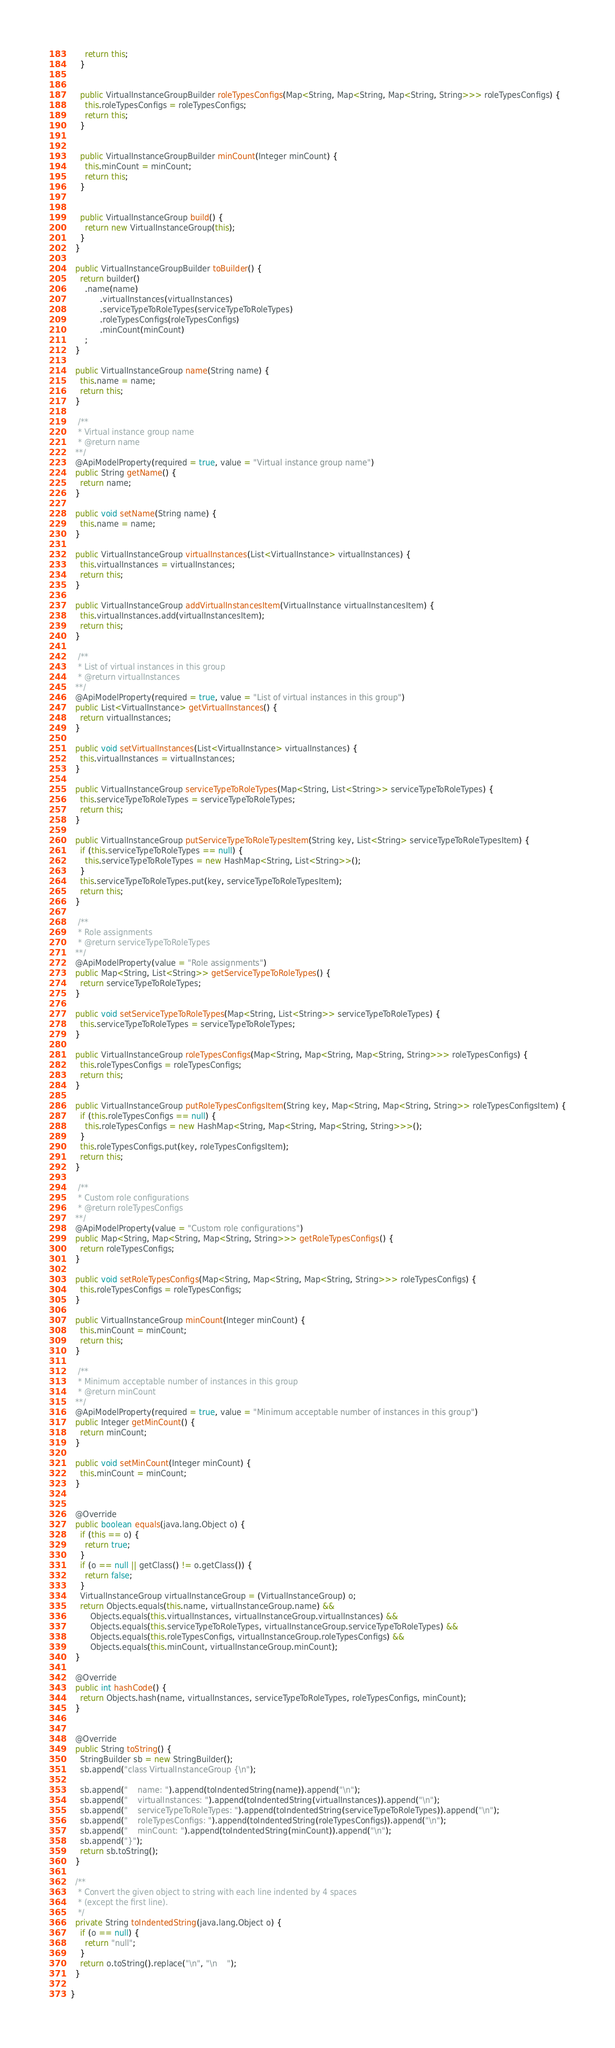Convert code to text. <code><loc_0><loc_0><loc_500><loc_500><_Java_>      return this;
    }


    public VirtualInstanceGroupBuilder roleTypesConfigs(Map<String, Map<String, Map<String, String>>> roleTypesConfigs) {
      this.roleTypesConfigs = roleTypesConfigs;
      return this;
    }


    public VirtualInstanceGroupBuilder minCount(Integer minCount) {
      this.minCount = minCount;
      return this;
    }


    public VirtualInstanceGroup build() {
      return new VirtualInstanceGroup(this);
    }
  }

  public VirtualInstanceGroupBuilder toBuilder() {
    return builder()
      .name(name)
            .virtualInstances(virtualInstances)
            .serviceTypeToRoleTypes(serviceTypeToRoleTypes)
            .roleTypesConfigs(roleTypesConfigs)
            .minCount(minCount)
      ;
  }

  public VirtualInstanceGroup name(String name) {
    this.name = name;
    return this;
  }

   /**
   * Virtual instance group name
   * @return name
  **/
  @ApiModelProperty(required = true, value = "Virtual instance group name")
  public String getName() {
    return name;
  }

  public void setName(String name) {
    this.name = name;
  }

  public VirtualInstanceGroup virtualInstances(List<VirtualInstance> virtualInstances) {
    this.virtualInstances = virtualInstances;
    return this;
  }

  public VirtualInstanceGroup addVirtualInstancesItem(VirtualInstance virtualInstancesItem) {
    this.virtualInstances.add(virtualInstancesItem);
    return this;
  }

   /**
   * List of virtual instances in this group
   * @return virtualInstances
  **/
  @ApiModelProperty(required = true, value = "List of virtual instances in this group")
  public List<VirtualInstance> getVirtualInstances() {
    return virtualInstances;
  }

  public void setVirtualInstances(List<VirtualInstance> virtualInstances) {
    this.virtualInstances = virtualInstances;
  }

  public VirtualInstanceGroup serviceTypeToRoleTypes(Map<String, List<String>> serviceTypeToRoleTypes) {
    this.serviceTypeToRoleTypes = serviceTypeToRoleTypes;
    return this;
  }

  public VirtualInstanceGroup putServiceTypeToRoleTypesItem(String key, List<String> serviceTypeToRoleTypesItem) {
    if (this.serviceTypeToRoleTypes == null) {
      this.serviceTypeToRoleTypes = new HashMap<String, List<String>>();
    }
    this.serviceTypeToRoleTypes.put(key, serviceTypeToRoleTypesItem);
    return this;
  }

   /**
   * Role assignments
   * @return serviceTypeToRoleTypes
  **/
  @ApiModelProperty(value = "Role assignments")
  public Map<String, List<String>> getServiceTypeToRoleTypes() {
    return serviceTypeToRoleTypes;
  }

  public void setServiceTypeToRoleTypes(Map<String, List<String>> serviceTypeToRoleTypes) {
    this.serviceTypeToRoleTypes = serviceTypeToRoleTypes;
  }

  public VirtualInstanceGroup roleTypesConfigs(Map<String, Map<String, Map<String, String>>> roleTypesConfigs) {
    this.roleTypesConfigs = roleTypesConfigs;
    return this;
  }

  public VirtualInstanceGroup putRoleTypesConfigsItem(String key, Map<String, Map<String, String>> roleTypesConfigsItem) {
    if (this.roleTypesConfigs == null) {
      this.roleTypesConfigs = new HashMap<String, Map<String, Map<String, String>>>();
    }
    this.roleTypesConfigs.put(key, roleTypesConfigsItem);
    return this;
  }

   /**
   * Custom role configurations
   * @return roleTypesConfigs
  **/
  @ApiModelProperty(value = "Custom role configurations")
  public Map<String, Map<String, Map<String, String>>> getRoleTypesConfigs() {
    return roleTypesConfigs;
  }

  public void setRoleTypesConfigs(Map<String, Map<String, Map<String, String>>> roleTypesConfigs) {
    this.roleTypesConfigs = roleTypesConfigs;
  }

  public VirtualInstanceGroup minCount(Integer minCount) {
    this.minCount = minCount;
    return this;
  }

   /**
   * Minimum acceptable number of instances in this group
   * @return minCount
  **/
  @ApiModelProperty(required = true, value = "Minimum acceptable number of instances in this group")
  public Integer getMinCount() {
    return minCount;
  }

  public void setMinCount(Integer minCount) {
    this.minCount = minCount;
  }


  @Override
  public boolean equals(java.lang.Object o) {
    if (this == o) {
      return true;
    }
    if (o == null || getClass() != o.getClass()) {
      return false;
    }
    VirtualInstanceGroup virtualInstanceGroup = (VirtualInstanceGroup) o;
    return Objects.equals(this.name, virtualInstanceGroup.name) &&
        Objects.equals(this.virtualInstances, virtualInstanceGroup.virtualInstances) &&
        Objects.equals(this.serviceTypeToRoleTypes, virtualInstanceGroup.serviceTypeToRoleTypes) &&
        Objects.equals(this.roleTypesConfigs, virtualInstanceGroup.roleTypesConfigs) &&
        Objects.equals(this.minCount, virtualInstanceGroup.minCount);
  }

  @Override
  public int hashCode() {
    return Objects.hash(name, virtualInstances, serviceTypeToRoleTypes, roleTypesConfigs, minCount);
  }


  @Override
  public String toString() {
    StringBuilder sb = new StringBuilder();
    sb.append("class VirtualInstanceGroup {\n");
    
    sb.append("    name: ").append(toIndentedString(name)).append("\n");
    sb.append("    virtualInstances: ").append(toIndentedString(virtualInstances)).append("\n");
    sb.append("    serviceTypeToRoleTypes: ").append(toIndentedString(serviceTypeToRoleTypes)).append("\n");
    sb.append("    roleTypesConfigs: ").append(toIndentedString(roleTypesConfigs)).append("\n");
    sb.append("    minCount: ").append(toIndentedString(minCount)).append("\n");
    sb.append("}");
    return sb.toString();
  }

  /**
   * Convert the given object to string with each line indented by 4 spaces
   * (except the first line).
   */
  private String toIndentedString(java.lang.Object o) {
    if (o == null) {
      return "null";
    }
    return o.toString().replace("\n", "\n    ");
  }

}

</code> 